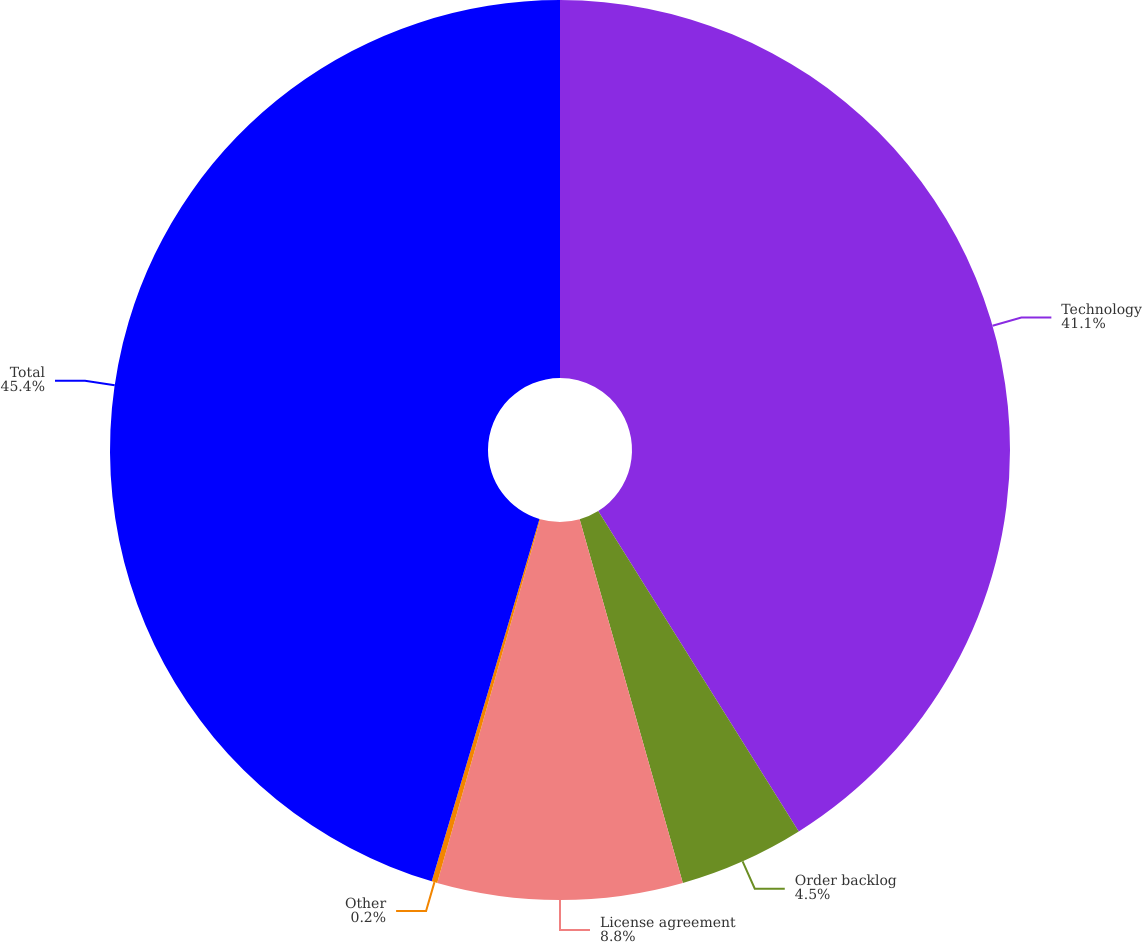Convert chart to OTSL. <chart><loc_0><loc_0><loc_500><loc_500><pie_chart><fcel>Technology<fcel>Order backlog<fcel>License agreement<fcel>Other<fcel>Total<nl><fcel>41.1%<fcel>4.5%<fcel>8.8%<fcel>0.2%<fcel>45.4%<nl></chart> 